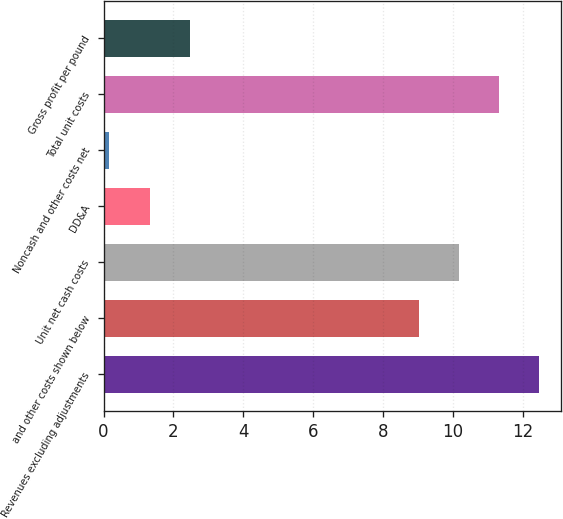<chart> <loc_0><loc_0><loc_500><loc_500><bar_chart><fcel>Revenues excluding adjustments<fcel>and other costs shown below<fcel>Unit net cash costs<fcel>DD&A<fcel>Noncash and other costs net<fcel>Total unit costs<fcel>Gross profit per pound<nl><fcel>12.48<fcel>9.03<fcel>10.18<fcel>1.32<fcel>0.17<fcel>11.33<fcel>2.47<nl></chart> 